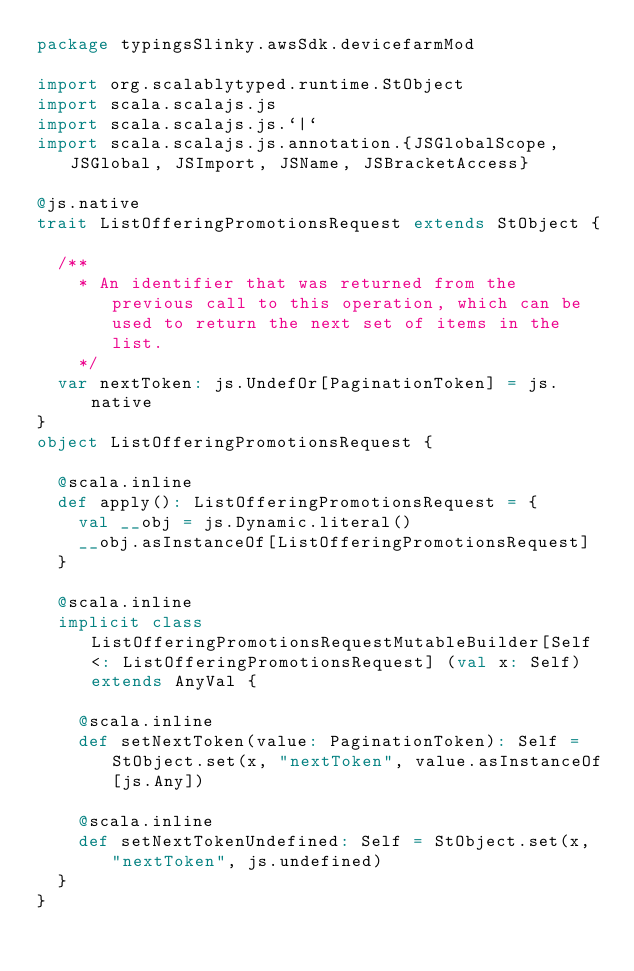Convert code to text. <code><loc_0><loc_0><loc_500><loc_500><_Scala_>package typingsSlinky.awsSdk.devicefarmMod

import org.scalablytyped.runtime.StObject
import scala.scalajs.js
import scala.scalajs.js.`|`
import scala.scalajs.js.annotation.{JSGlobalScope, JSGlobal, JSImport, JSName, JSBracketAccess}

@js.native
trait ListOfferingPromotionsRequest extends StObject {
  
  /**
    * An identifier that was returned from the previous call to this operation, which can be used to return the next set of items in the list.
    */
  var nextToken: js.UndefOr[PaginationToken] = js.native
}
object ListOfferingPromotionsRequest {
  
  @scala.inline
  def apply(): ListOfferingPromotionsRequest = {
    val __obj = js.Dynamic.literal()
    __obj.asInstanceOf[ListOfferingPromotionsRequest]
  }
  
  @scala.inline
  implicit class ListOfferingPromotionsRequestMutableBuilder[Self <: ListOfferingPromotionsRequest] (val x: Self) extends AnyVal {
    
    @scala.inline
    def setNextToken(value: PaginationToken): Self = StObject.set(x, "nextToken", value.asInstanceOf[js.Any])
    
    @scala.inline
    def setNextTokenUndefined: Self = StObject.set(x, "nextToken", js.undefined)
  }
}
</code> 